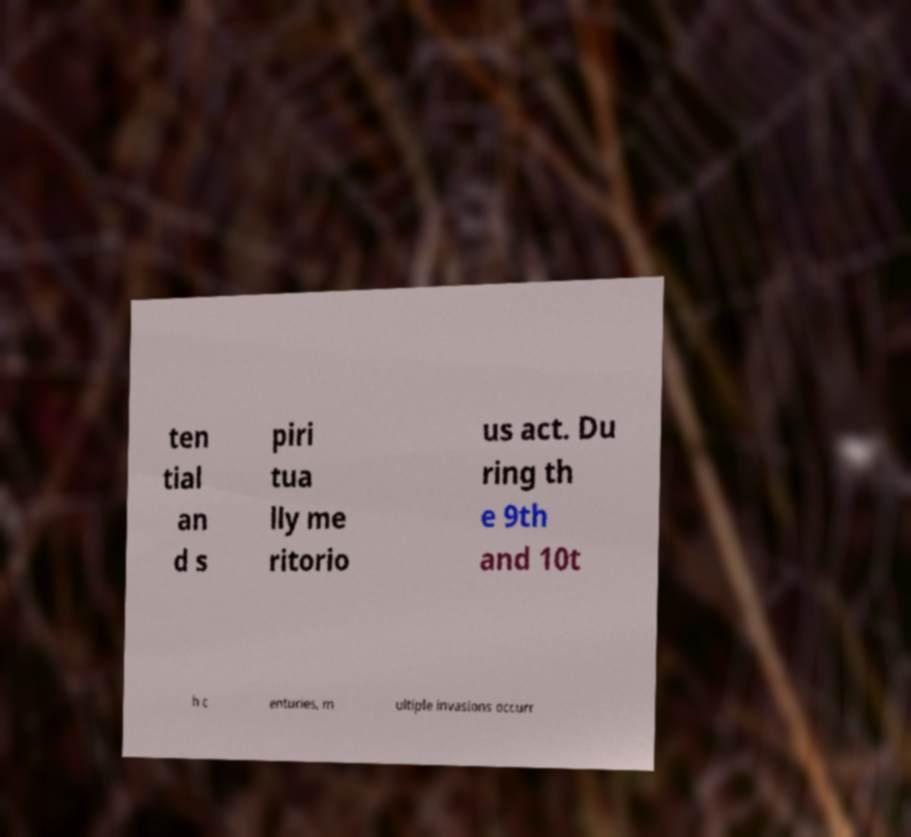I need the written content from this picture converted into text. Can you do that? ten tial an d s piri tua lly me ritorio us act. Du ring th e 9th and 10t h c enturies, m ultiple invasions occurr 